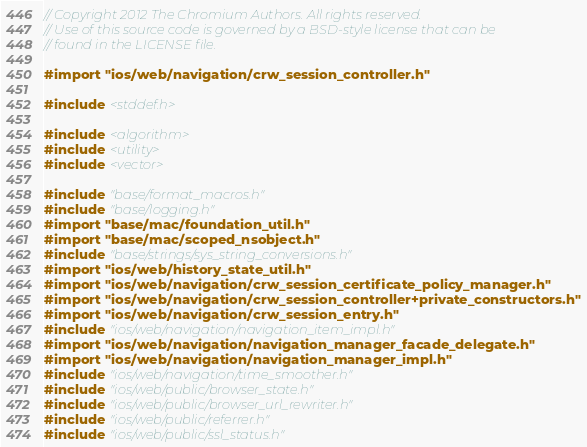<code> <loc_0><loc_0><loc_500><loc_500><_ObjectiveC_>// Copyright 2012 The Chromium Authors. All rights reserved.
// Use of this source code is governed by a BSD-style license that can be
// found in the LICENSE file.

#import "ios/web/navigation/crw_session_controller.h"

#include <stddef.h>

#include <algorithm>
#include <utility>
#include <vector>

#include "base/format_macros.h"
#include "base/logging.h"
#import "base/mac/foundation_util.h"
#import "base/mac/scoped_nsobject.h"
#include "base/strings/sys_string_conversions.h"
#import "ios/web/history_state_util.h"
#import "ios/web/navigation/crw_session_certificate_policy_manager.h"
#import "ios/web/navigation/crw_session_controller+private_constructors.h"
#import "ios/web/navigation/crw_session_entry.h"
#include "ios/web/navigation/navigation_item_impl.h"
#import "ios/web/navigation/navigation_manager_facade_delegate.h"
#import "ios/web/navigation/navigation_manager_impl.h"
#include "ios/web/navigation/time_smoother.h"
#include "ios/web/public/browser_state.h"
#include "ios/web/public/browser_url_rewriter.h"
#include "ios/web/public/referrer.h"
#include "ios/web/public/ssl_status.h"
</code> 